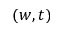Convert formula to latex. <formula><loc_0><loc_0><loc_500><loc_500>( w , t )</formula> 